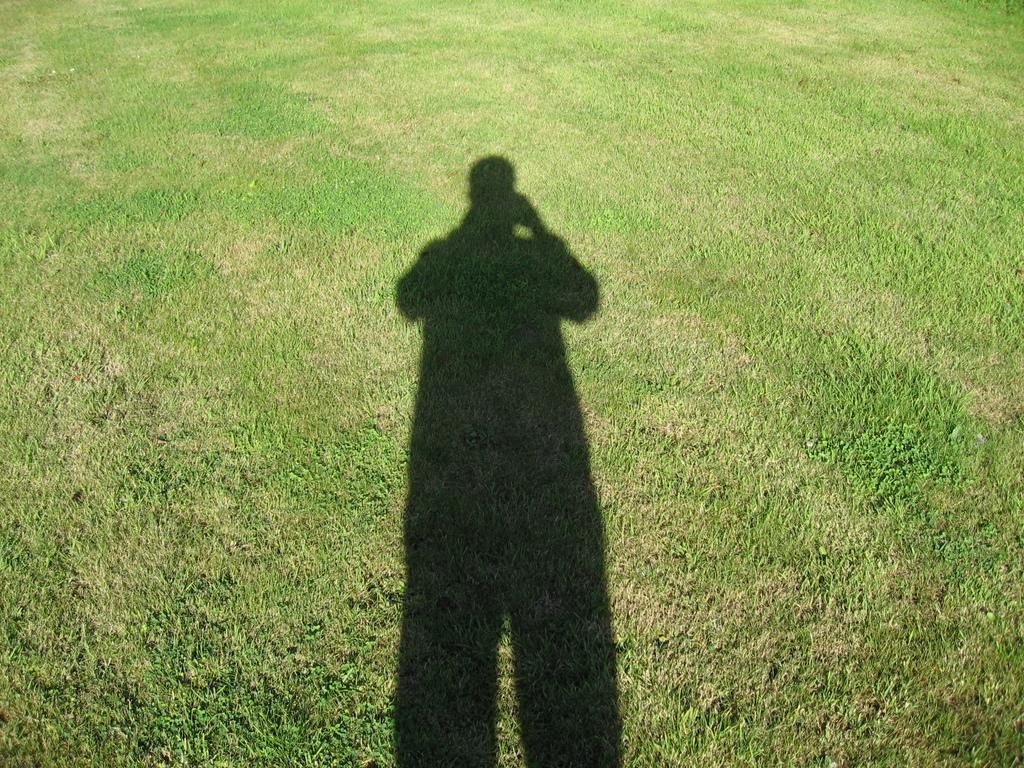What can be seen in the image that is not a solid object? There is a person's shadow in the image. What color is the grass in the image? The grass is green in the image. What type of insect can be seen crawling on the person's shadow in the image? There is no insect present in the image; it only shows a person's shadow and green grass. What payment method is accepted for the services provided in the image? There is no service or payment method depicted in the image, as it only shows a person's shadow and green grass. 